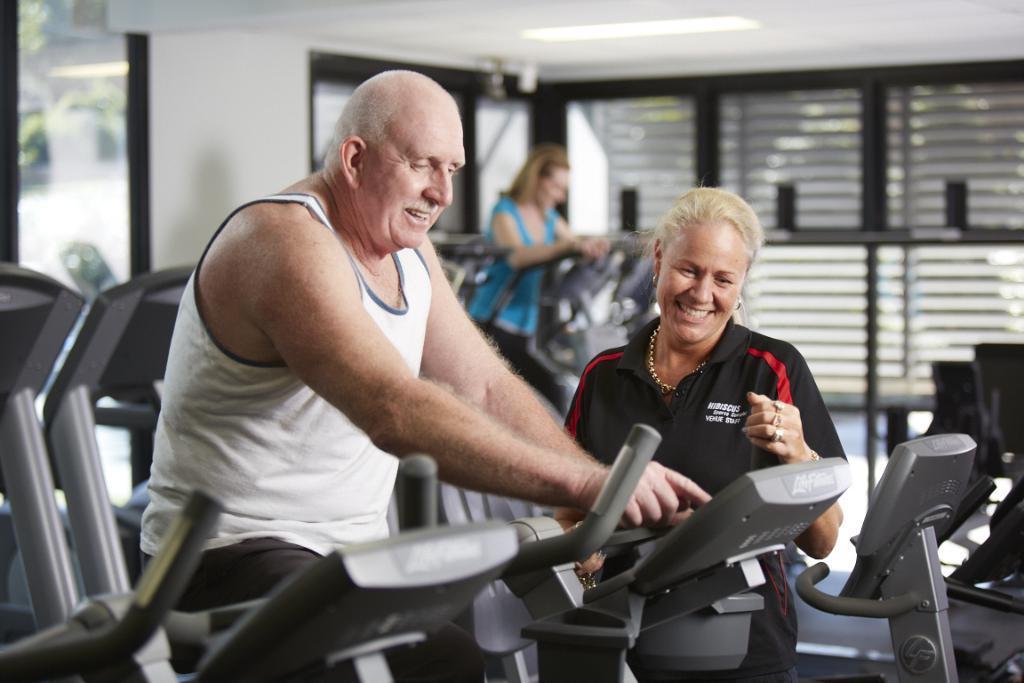In one or two sentences, can you explain what this image depicts? In this image two persons doing cycling. Beside the person who is wearing white T-shirt there is a women. At the background there is a door. 